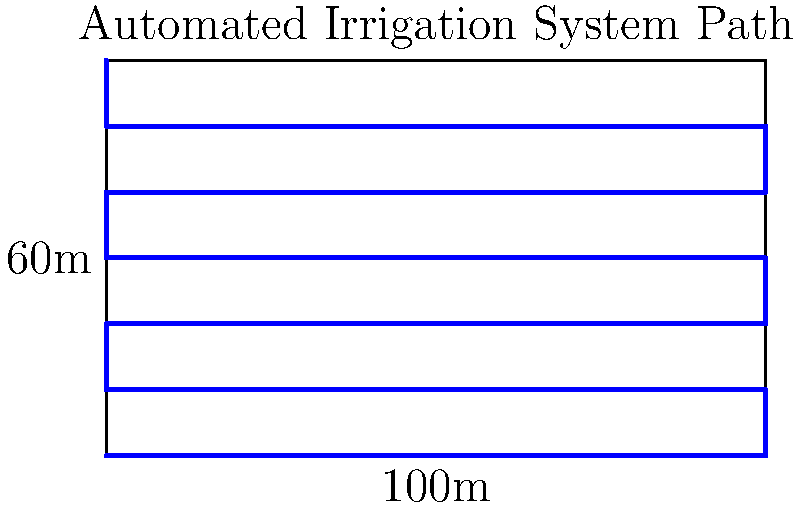Given a rectangular field with dimensions 100m x 60m, what is the total distance traveled by an automated irrigation system that follows a back-and-forth pattern with 10m spacing between passes? Assume the system starts at one corner and ends at the opposite corner. To calculate the total distance traveled by the automated irrigation system, we need to follow these steps:

1. Determine the number of passes:
   - Field height = 60m
   - Spacing between passes = 10m
   - Number of passes = 60m ÷ 10m = 6 passes

2. Calculate the distance for each pass:
   - Field width = 100m
   - Distance per pass = 100m

3. Calculate the total horizontal distance:
   - Horizontal distance = Number of passes × Distance per pass
   - Horizontal distance = 6 × 100m = 600m

4. Calculate the vertical distance:
   - The system moves vertically 5 times (between 6 passes)
   - Vertical distance per move = 10m
   - Total vertical distance = 5 × 10m = 50m

5. Sum up the total distance:
   - Total distance = Horizontal distance + Vertical distance
   - Total distance = 600m + 50m = 650m

Therefore, the automated irrigation system travels a total distance of 650 meters to cover the entire field.
Answer: 650m 